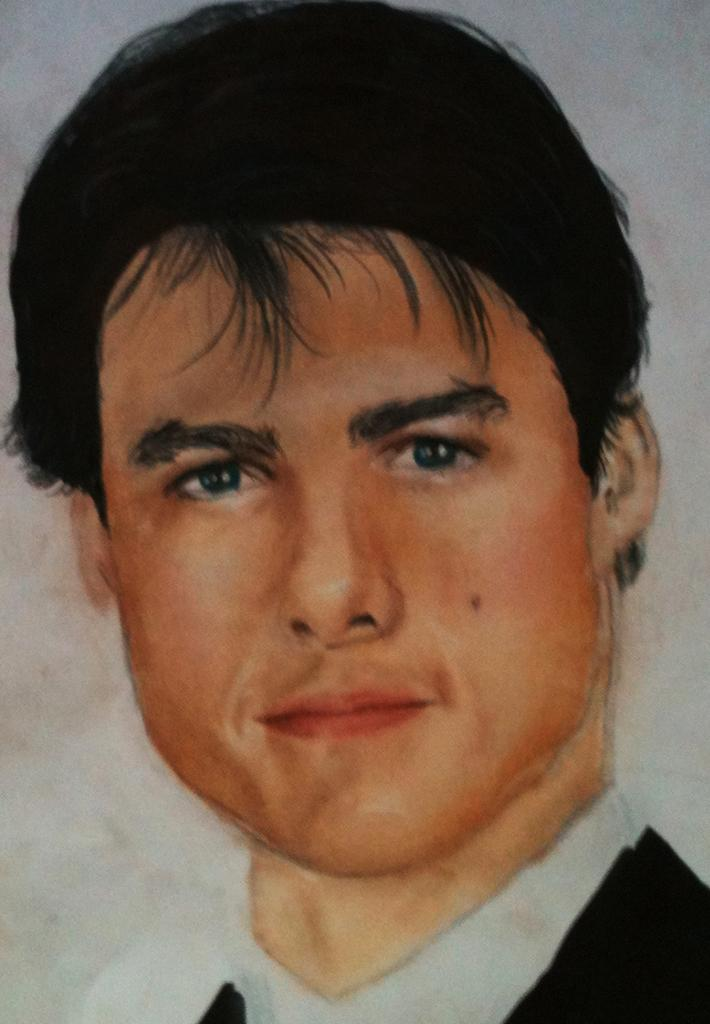What is depicted in the image? The image contains a painting of a man. What is the man wearing in the painting? The man is wearing a black and white dress in the painting. What can be seen in the background of the painting? There is a wall in the background of the painting. What type of drug is the man using in the painting? There is no drug present in the painting; it depicts a man wearing a black and white dress in front of a wall. 